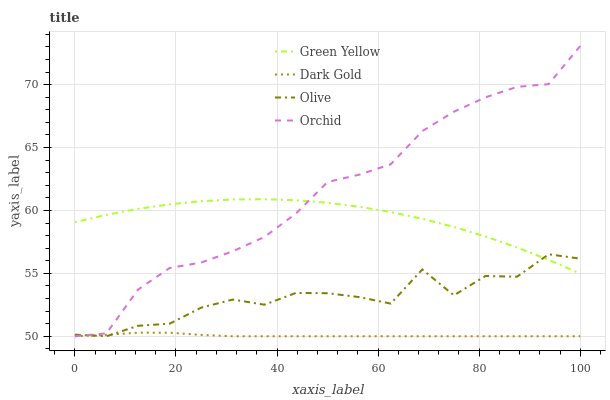Does Dark Gold have the minimum area under the curve?
Answer yes or no. Yes. Does Orchid have the maximum area under the curve?
Answer yes or no. Yes. Does Green Yellow have the minimum area under the curve?
Answer yes or no. No. Does Green Yellow have the maximum area under the curve?
Answer yes or no. No. Is Dark Gold the smoothest?
Answer yes or no. Yes. Is Olive the roughest?
Answer yes or no. Yes. Is Green Yellow the smoothest?
Answer yes or no. No. Is Green Yellow the roughest?
Answer yes or no. No. Does Green Yellow have the lowest value?
Answer yes or no. No. Does Orchid have the highest value?
Answer yes or no. Yes. Does Green Yellow have the highest value?
Answer yes or no. No. Is Dark Gold less than Green Yellow?
Answer yes or no. Yes. Is Green Yellow greater than Dark Gold?
Answer yes or no. Yes. Does Dark Gold intersect Green Yellow?
Answer yes or no. No. 